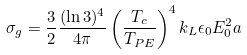Convert formula to latex. <formula><loc_0><loc_0><loc_500><loc_500>\sigma _ { g } = \frac { 3 } { 2 } \frac { ( \ln 3 ) ^ { 4 } } { 4 \pi } \left ( \frac { T _ { c } } { T _ { P E } } \right ) ^ { 4 } k _ { L } \epsilon _ { 0 } E _ { 0 } ^ { 2 } a</formula> 